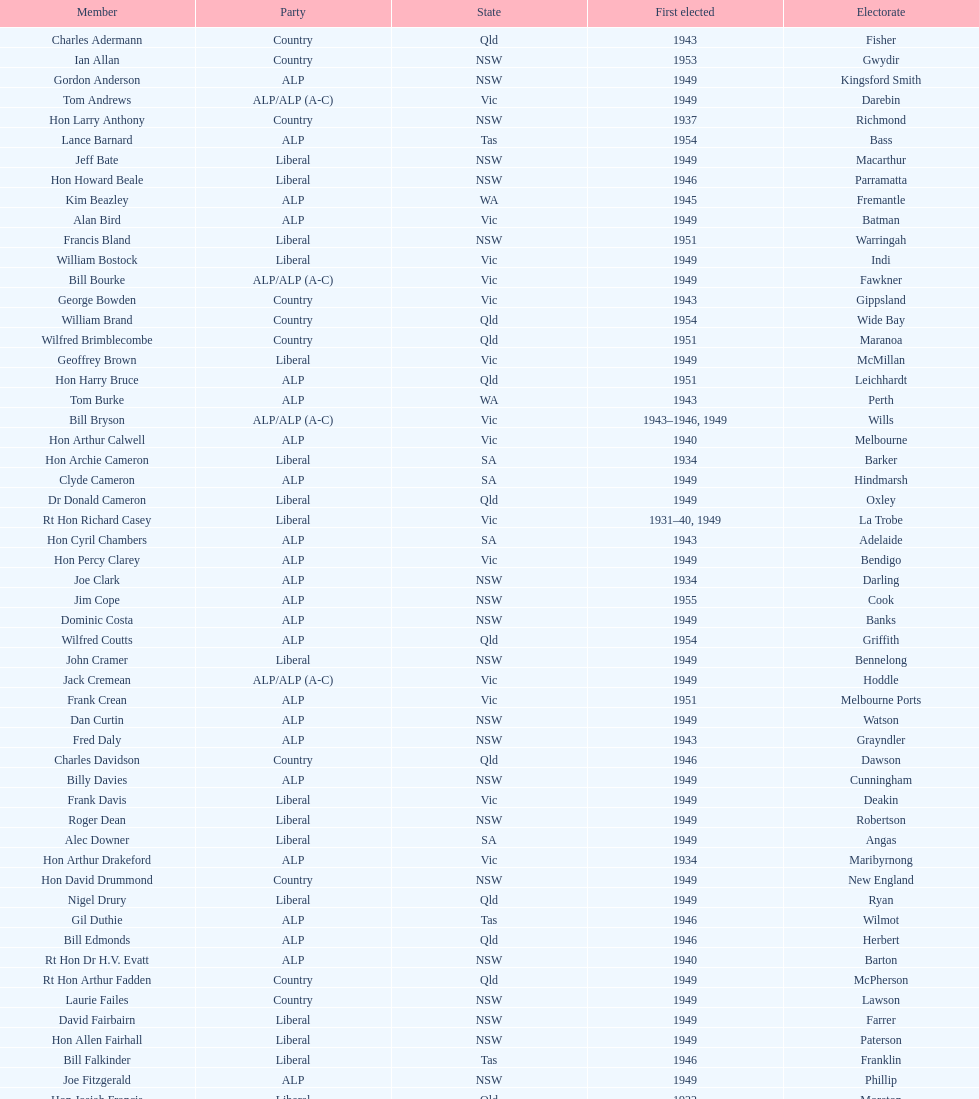When was joe clark first elected? 1934. 